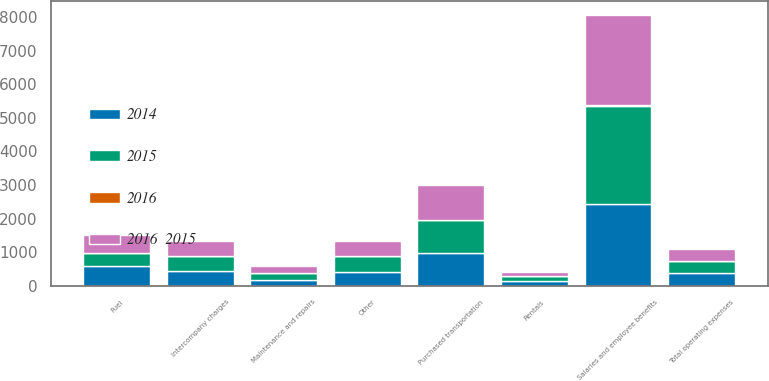<chart> <loc_0><loc_0><loc_500><loc_500><stacked_bar_chart><ecel><fcel>Salaries and employee benefits<fcel>Purchased transportation<fcel>Rentals<fcel>Fuel<fcel>Maintenance and repairs<fcel>Intercompany charges<fcel>Other<fcel>Total operating expenses<nl><fcel>2015<fcel>2925<fcel>962<fcel>142<fcel>363<fcel>206<fcel>456<fcel>472<fcel>363<nl><fcel>2016  2015<fcel>2698<fcel>1045<fcel>129<fcel>508<fcel>201<fcel>444<fcel>452<fcel>363<nl><fcel>2014<fcel>2442<fcel>981<fcel>131<fcel>595<fcel>179<fcel>431<fcel>416<fcel>363<nl><fcel>2016<fcel>8<fcel>8<fcel>10<fcel>29<fcel>2<fcel>3<fcel>4<fcel>1<nl></chart> 